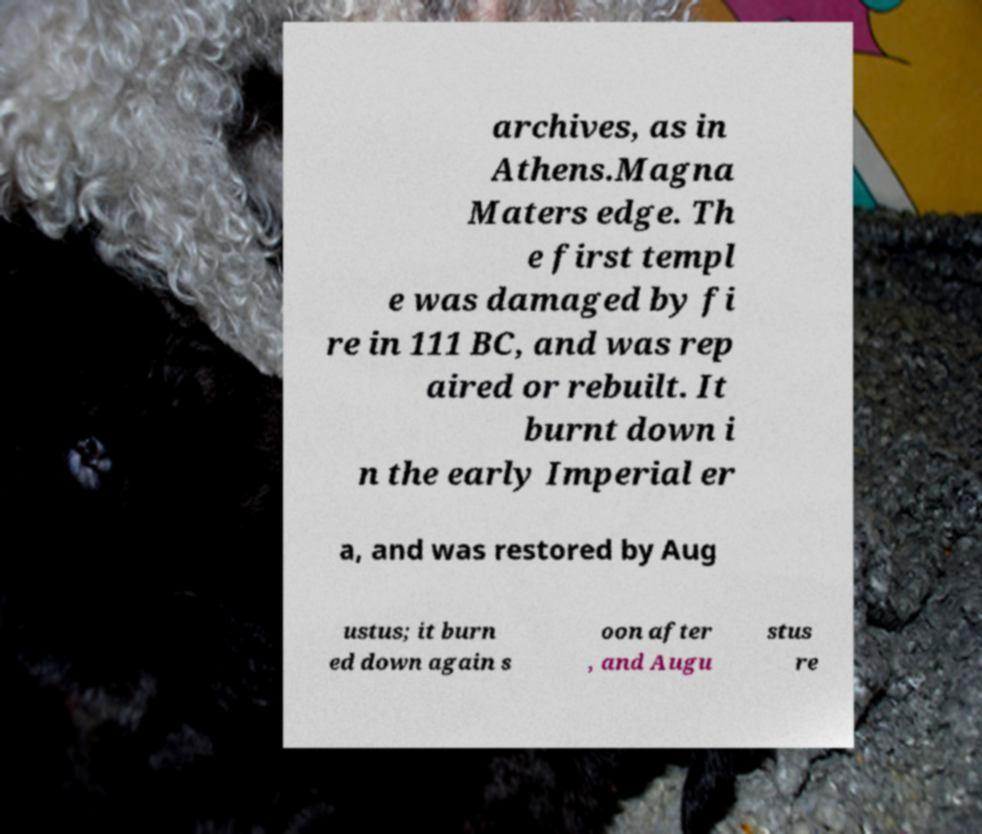What messages or text are displayed in this image? I need them in a readable, typed format. archives, as in Athens.Magna Maters edge. Th e first templ e was damaged by fi re in 111 BC, and was rep aired or rebuilt. It burnt down i n the early Imperial er a, and was restored by Aug ustus; it burn ed down again s oon after , and Augu stus re 